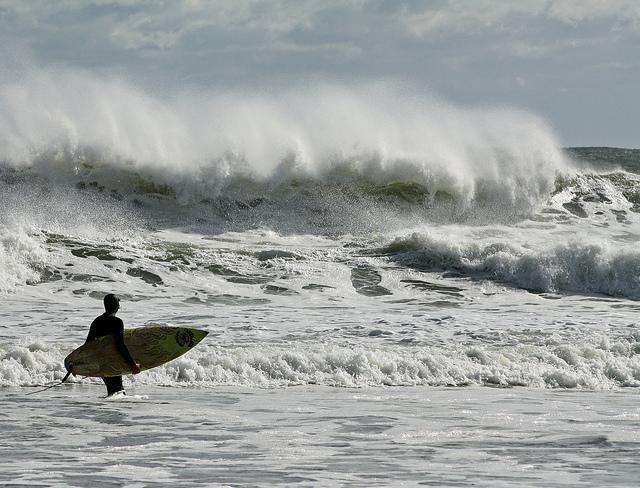How many people are in the water?
Give a very brief answer. 1. 